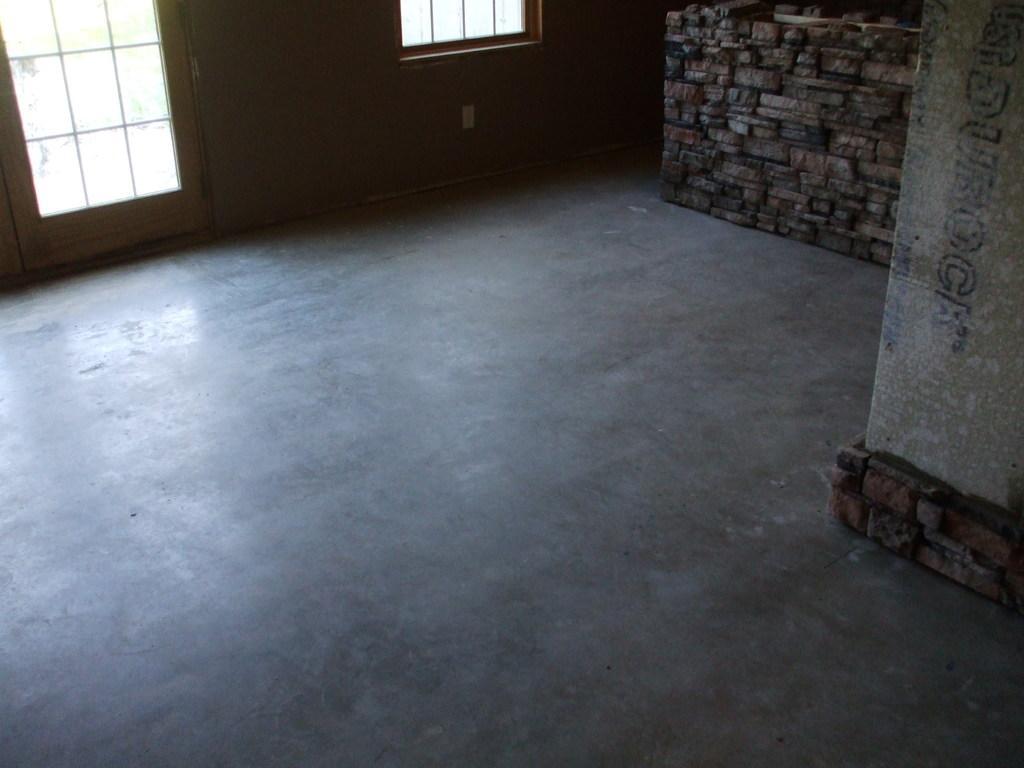How would you summarize this image in a sentence or two? In this picture there is a bricks wall at the top side of the image and there are windows on the left side of the image. 